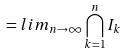Convert formula to latex. <formula><loc_0><loc_0><loc_500><loc_500>= l i m _ { n \rightarrow \infty } \bigcap _ { k = 1 } ^ { n } I _ { k }</formula> 